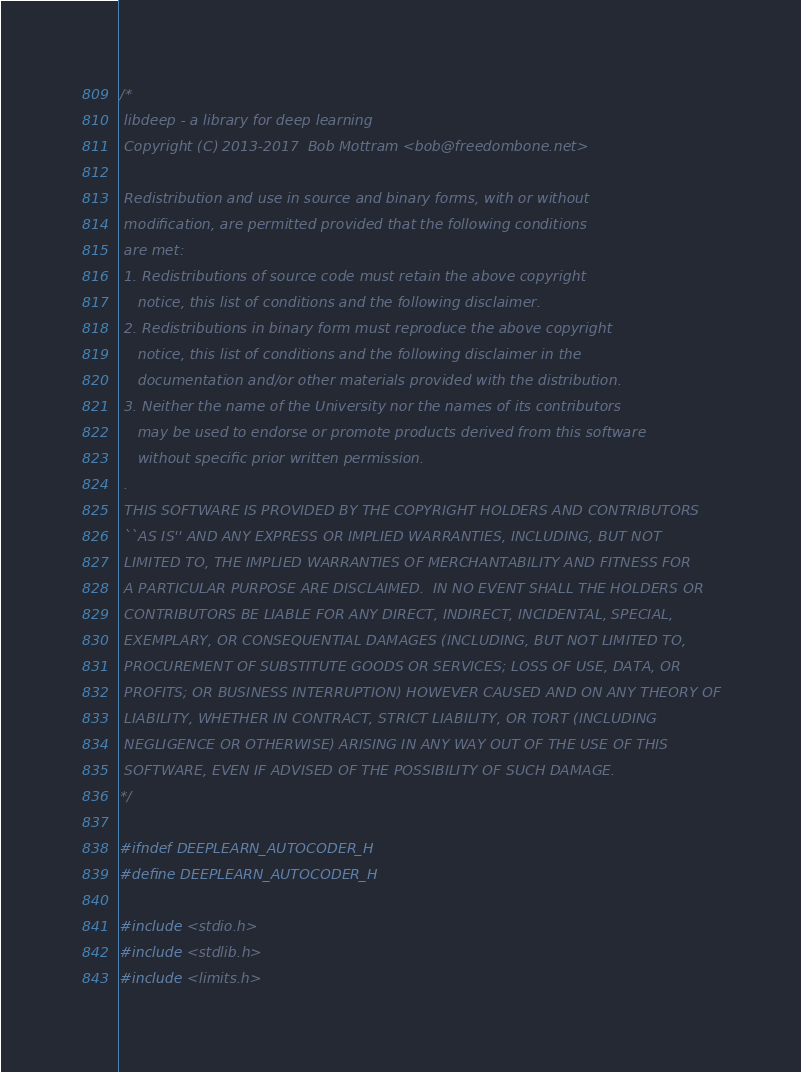<code> <loc_0><loc_0><loc_500><loc_500><_C_>/*
 libdeep - a library for deep learning
 Copyright (C) 2013-2017  Bob Mottram <bob@freedombone.net>

 Redistribution and use in source and binary forms, with or without
 modification, are permitted provided that the following conditions
 are met:
 1. Redistributions of source code must retain the above copyright
    notice, this list of conditions and the following disclaimer.
 2. Redistributions in binary form must reproduce the above copyright
    notice, this list of conditions and the following disclaimer in the
    documentation and/or other materials provided with the distribution.
 3. Neither the name of the University nor the names of its contributors
    may be used to endorse or promote products derived from this software
    without specific prior written permission.
 .
 THIS SOFTWARE IS PROVIDED BY THE COPYRIGHT HOLDERS AND CONTRIBUTORS
 ``AS IS'' AND ANY EXPRESS OR IMPLIED WARRANTIES, INCLUDING, BUT NOT
 LIMITED TO, THE IMPLIED WARRANTIES OF MERCHANTABILITY AND FITNESS FOR
 A PARTICULAR PURPOSE ARE DISCLAIMED.  IN NO EVENT SHALL THE HOLDERS OR
 CONTRIBUTORS BE LIABLE FOR ANY DIRECT, INDIRECT, INCIDENTAL, SPECIAL,
 EXEMPLARY, OR CONSEQUENTIAL DAMAGES (INCLUDING, BUT NOT LIMITED TO,
 PROCUREMENT OF SUBSTITUTE GOODS OR SERVICES; LOSS OF USE, DATA, OR
 PROFITS; OR BUSINESS INTERRUPTION) HOWEVER CAUSED AND ON ANY THEORY OF
 LIABILITY, WHETHER IN CONTRACT, STRICT LIABILITY, OR TORT (INCLUDING
 NEGLIGENCE OR OTHERWISE) ARISING IN ANY WAY OUT OF THE USE OF THIS
 SOFTWARE, EVEN IF ADVISED OF THE POSSIBILITY OF SUCH DAMAGE.
*/

#ifndef DEEPLEARN_AUTOCODER_H
#define DEEPLEARN_AUTOCODER_H

#include <stdio.h>
#include <stdlib.h>
#include <limits.h></code> 